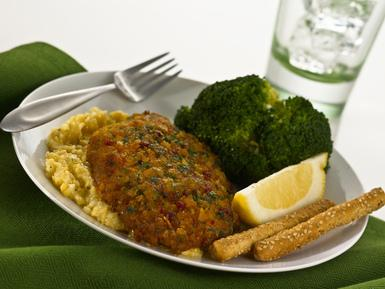Which item on the plate likely is highest in vitamins and minerals?

Choices:
A) grits
B) crab cake
C) lemon
D) broccoli broccoli 